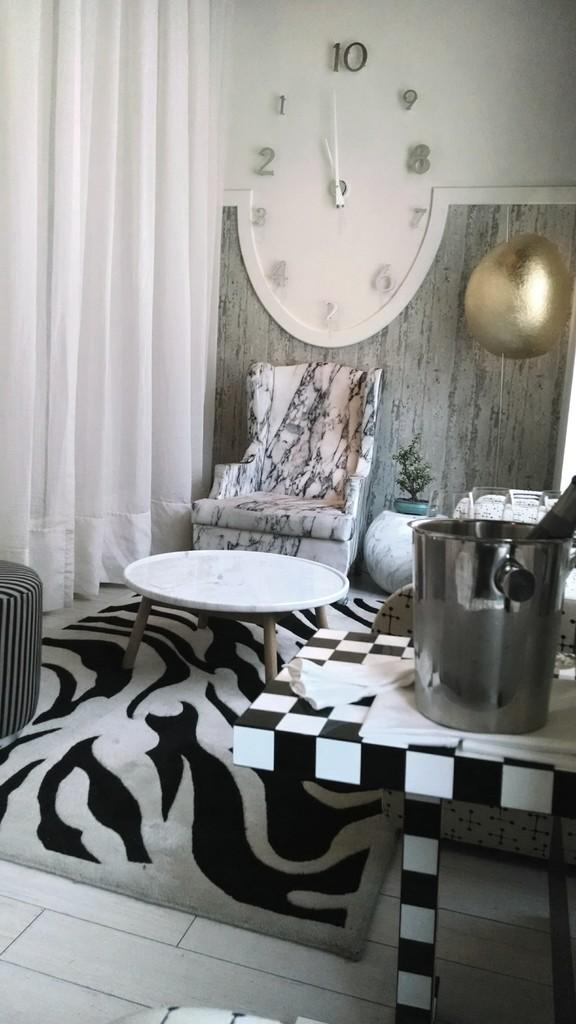<image>
Describe the image concisely. A room with a clock showing it's hands on 1 and 10 